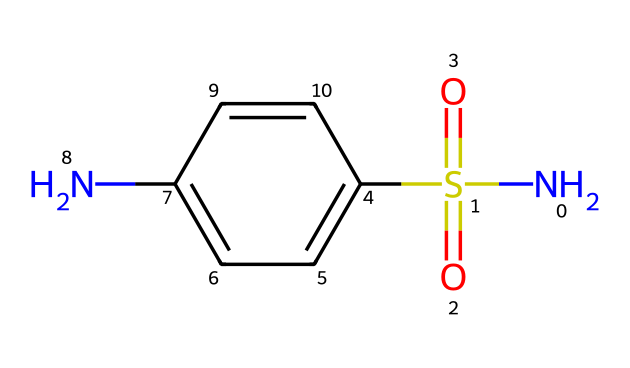What is the primary functional group present in sulfanilamide? The primary functional group in the structure is the sulfonamide group, indicated by the presence of the sulfur atom bonded to two oxygen atoms (S(=O)(=O)) and an amine (N) group.
Answer: sulfonamide How many carbon atoms are in the sulfanilamide structure? By counting the carbon atoms in the benzene ring and the carbon atom directly connected to the sulfonamide, we find a total of six carbon atoms in the structure.
Answer: six What is the oxidation state of the sulfur atom in this compound? The sulfur atom in sulfanilamide is bonded to two oxygen atoms with double bonds, thus it has an oxidation state of +6, which is typical for sulfur in sulfonamide compounds.
Answer: +6 Which atom in the structure contributes to the antibacterial activity of sulfanilamide? The nitrogen atom in the sulfonamide group is crucial for the antibacterial activity, as it interacts with bacterial enzymes, inhibiting their function.
Answer: nitrogen What type of bond is formed between the nitrogen atom and the sulfur atom in sulfanilamide? The bond formed is a covalent bond, where the nitrogen shares electrons with the sulfur, characteristic of the amide functional group in this compound.
Answer: covalent How many hydrogen atoms are present in sulfanilamide? The structure contains a total of eight hydrogen atoms; five from the benzene ring and three attached to the amine group, resulting in a total count of hydrogen atoms.
Answer: eight What class of compounds does sulfanilamide belong to? Sulfanilamide belongs to the class of compounds known as sulfonamides, specifically because of its sulfonamide functional group, which defines its pharmacological properties.
Answer: sulfonamides 